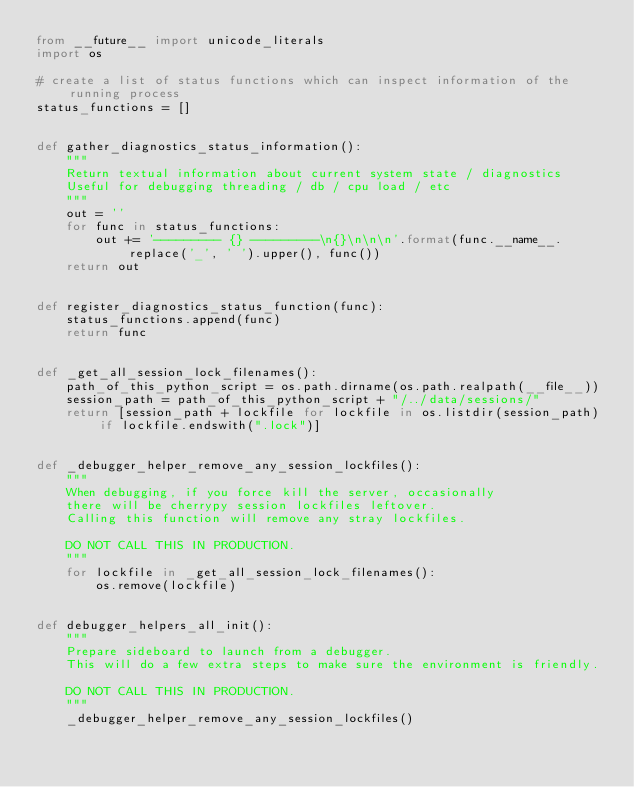<code> <loc_0><loc_0><loc_500><loc_500><_Python_>from __future__ import unicode_literals
import os

# create a list of status functions which can inspect information of the running process
status_functions = []


def gather_diagnostics_status_information():
    """
    Return textual information about current system state / diagnostics
    Useful for debugging threading / db / cpu load / etc
    """
    out = ''
    for func in status_functions:
        out += '--------- {} ---------\n{}\n\n\n'.format(func.__name__.replace('_', ' ').upper(), func())
    return out


def register_diagnostics_status_function(func):
    status_functions.append(func)
    return func


def _get_all_session_lock_filenames():
    path_of_this_python_script = os.path.dirname(os.path.realpath(__file__))
    session_path = path_of_this_python_script + "/../data/sessions/"
    return [session_path + lockfile for lockfile in os.listdir(session_path) if lockfile.endswith(".lock")]


def _debugger_helper_remove_any_session_lockfiles():
    """
    When debugging, if you force kill the server, occasionally
    there will be cherrypy session lockfiles leftover.
    Calling this function will remove any stray lockfiles.

    DO NOT CALL THIS IN PRODUCTION.
    """
    for lockfile in _get_all_session_lock_filenames():
        os.remove(lockfile)


def debugger_helpers_all_init():
    """
    Prepare sideboard to launch from a debugger.
    This will do a few extra steps to make sure the environment is friendly.

    DO NOT CALL THIS IN PRODUCTION.
    """
    _debugger_helper_remove_any_session_lockfiles()
</code> 